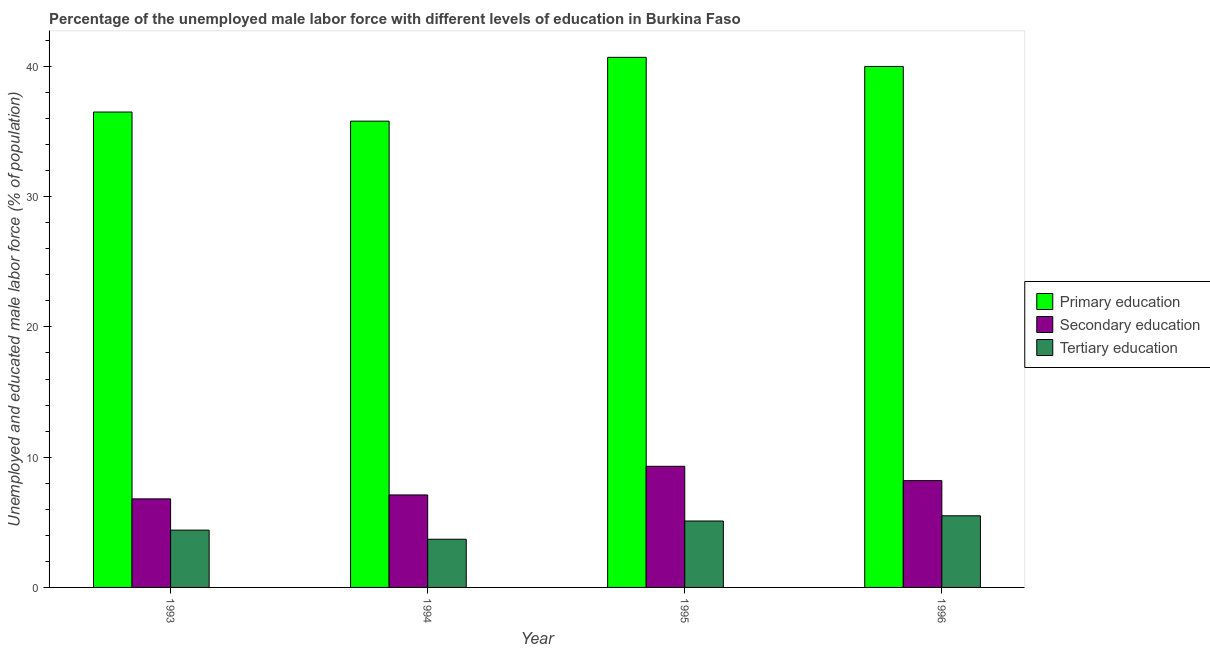How many bars are there on the 3rd tick from the right?
Your answer should be very brief. 3. What is the percentage of male labor force who received tertiary education in 1995?
Your response must be concise. 5.1. Across all years, what is the maximum percentage of male labor force who received secondary education?
Give a very brief answer. 9.3. Across all years, what is the minimum percentage of male labor force who received tertiary education?
Keep it short and to the point. 3.7. In which year was the percentage of male labor force who received secondary education maximum?
Keep it short and to the point. 1995. In which year was the percentage of male labor force who received primary education minimum?
Give a very brief answer. 1994. What is the total percentage of male labor force who received tertiary education in the graph?
Offer a terse response. 18.7. What is the difference between the percentage of male labor force who received secondary education in 1993 and that in 1996?
Ensure brevity in your answer.  -1.4. What is the difference between the percentage of male labor force who received tertiary education in 1993 and the percentage of male labor force who received secondary education in 1994?
Offer a terse response. 0.7. What is the average percentage of male labor force who received tertiary education per year?
Your answer should be very brief. 4.68. In how many years, is the percentage of male labor force who received primary education greater than 4 %?
Offer a very short reply. 4. What is the ratio of the percentage of male labor force who received primary education in 1994 to that in 1996?
Your answer should be very brief. 0.89. Is the percentage of male labor force who received tertiary education in 1993 less than that in 1995?
Give a very brief answer. Yes. Is the difference between the percentage of male labor force who received primary education in 1995 and 1996 greater than the difference between the percentage of male labor force who received secondary education in 1995 and 1996?
Provide a succinct answer. No. What is the difference between the highest and the second highest percentage of male labor force who received tertiary education?
Ensure brevity in your answer.  0.4. What is the difference between the highest and the lowest percentage of male labor force who received primary education?
Your answer should be compact. 4.9. Is the sum of the percentage of male labor force who received secondary education in 1994 and 1996 greater than the maximum percentage of male labor force who received primary education across all years?
Keep it short and to the point. Yes. What does the 3rd bar from the left in 1994 represents?
Your answer should be very brief. Tertiary education. What does the 2nd bar from the right in 1993 represents?
Your answer should be very brief. Secondary education. How many bars are there?
Your response must be concise. 12. Are all the bars in the graph horizontal?
Make the answer very short. No. How many years are there in the graph?
Make the answer very short. 4. Where does the legend appear in the graph?
Offer a very short reply. Center right. How many legend labels are there?
Offer a very short reply. 3. How are the legend labels stacked?
Ensure brevity in your answer.  Vertical. What is the title of the graph?
Ensure brevity in your answer.  Percentage of the unemployed male labor force with different levels of education in Burkina Faso. What is the label or title of the Y-axis?
Provide a short and direct response. Unemployed and educated male labor force (% of population). What is the Unemployed and educated male labor force (% of population) in Primary education in 1993?
Offer a terse response. 36.5. What is the Unemployed and educated male labor force (% of population) in Secondary education in 1993?
Make the answer very short. 6.8. What is the Unemployed and educated male labor force (% of population) of Tertiary education in 1993?
Your answer should be compact. 4.4. What is the Unemployed and educated male labor force (% of population) of Primary education in 1994?
Provide a short and direct response. 35.8. What is the Unemployed and educated male labor force (% of population) in Secondary education in 1994?
Give a very brief answer. 7.1. What is the Unemployed and educated male labor force (% of population) in Tertiary education in 1994?
Your response must be concise. 3.7. What is the Unemployed and educated male labor force (% of population) of Primary education in 1995?
Ensure brevity in your answer.  40.7. What is the Unemployed and educated male labor force (% of population) in Secondary education in 1995?
Keep it short and to the point. 9.3. What is the Unemployed and educated male labor force (% of population) of Tertiary education in 1995?
Offer a terse response. 5.1. What is the Unemployed and educated male labor force (% of population) of Secondary education in 1996?
Provide a succinct answer. 8.2. Across all years, what is the maximum Unemployed and educated male labor force (% of population) of Primary education?
Keep it short and to the point. 40.7. Across all years, what is the maximum Unemployed and educated male labor force (% of population) in Secondary education?
Offer a terse response. 9.3. Across all years, what is the maximum Unemployed and educated male labor force (% of population) in Tertiary education?
Give a very brief answer. 5.5. Across all years, what is the minimum Unemployed and educated male labor force (% of population) of Primary education?
Your response must be concise. 35.8. Across all years, what is the minimum Unemployed and educated male labor force (% of population) of Secondary education?
Give a very brief answer. 6.8. Across all years, what is the minimum Unemployed and educated male labor force (% of population) in Tertiary education?
Your answer should be very brief. 3.7. What is the total Unemployed and educated male labor force (% of population) in Primary education in the graph?
Keep it short and to the point. 153. What is the total Unemployed and educated male labor force (% of population) in Secondary education in the graph?
Give a very brief answer. 31.4. What is the total Unemployed and educated male labor force (% of population) in Tertiary education in the graph?
Your response must be concise. 18.7. What is the difference between the Unemployed and educated male labor force (% of population) in Secondary education in 1993 and that in 1994?
Offer a very short reply. -0.3. What is the difference between the Unemployed and educated male labor force (% of population) of Tertiary education in 1993 and that in 1994?
Offer a very short reply. 0.7. What is the difference between the Unemployed and educated male labor force (% of population) of Secondary education in 1993 and that in 1995?
Your response must be concise. -2.5. What is the difference between the Unemployed and educated male labor force (% of population) in Tertiary education in 1993 and that in 1995?
Ensure brevity in your answer.  -0.7. What is the difference between the Unemployed and educated male labor force (% of population) in Secondary education in 1993 and that in 1996?
Keep it short and to the point. -1.4. What is the difference between the Unemployed and educated male labor force (% of population) in Tertiary education in 1993 and that in 1996?
Your response must be concise. -1.1. What is the difference between the Unemployed and educated male labor force (% of population) of Tertiary education in 1994 and that in 1995?
Provide a short and direct response. -1.4. What is the difference between the Unemployed and educated male labor force (% of population) of Primary education in 1994 and that in 1996?
Provide a succinct answer. -4.2. What is the difference between the Unemployed and educated male labor force (% of population) of Primary education in 1995 and that in 1996?
Keep it short and to the point. 0.7. What is the difference between the Unemployed and educated male labor force (% of population) in Primary education in 1993 and the Unemployed and educated male labor force (% of population) in Secondary education in 1994?
Provide a short and direct response. 29.4. What is the difference between the Unemployed and educated male labor force (% of population) of Primary education in 1993 and the Unemployed and educated male labor force (% of population) of Tertiary education in 1994?
Your answer should be very brief. 32.8. What is the difference between the Unemployed and educated male labor force (% of population) of Secondary education in 1993 and the Unemployed and educated male labor force (% of population) of Tertiary education in 1994?
Your answer should be very brief. 3.1. What is the difference between the Unemployed and educated male labor force (% of population) of Primary education in 1993 and the Unemployed and educated male labor force (% of population) of Secondary education in 1995?
Offer a very short reply. 27.2. What is the difference between the Unemployed and educated male labor force (% of population) of Primary education in 1993 and the Unemployed and educated male labor force (% of population) of Tertiary education in 1995?
Provide a succinct answer. 31.4. What is the difference between the Unemployed and educated male labor force (% of population) of Secondary education in 1993 and the Unemployed and educated male labor force (% of population) of Tertiary education in 1995?
Offer a terse response. 1.7. What is the difference between the Unemployed and educated male labor force (% of population) in Primary education in 1993 and the Unemployed and educated male labor force (% of population) in Secondary education in 1996?
Make the answer very short. 28.3. What is the difference between the Unemployed and educated male labor force (% of population) of Secondary education in 1993 and the Unemployed and educated male labor force (% of population) of Tertiary education in 1996?
Provide a short and direct response. 1.3. What is the difference between the Unemployed and educated male labor force (% of population) in Primary education in 1994 and the Unemployed and educated male labor force (% of population) in Secondary education in 1995?
Make the answer very short. 26.5. What is the difference between the Unemployed and educated male labor force (% of population) in Primary education in 1994 and the Unemployed and educated male labor force (% of population) in Tertiary education in 1995?
Provide a short and direct response. 30.7. What is the difference between the Unemployed and educated male labor force (% of population) in Primary education in 1994 and the Unemployed and educated male labor force (% of population) in Secondary education in 1996?
Your response must be concise. 27.6. What is the difference between the Unemployed and educated male labor force (% of population) in Primary education in 1994 and the Unemployed and educated male labor force (% of population) in Tertiary education in 1996?
Your response must be concise. 30.3. What is the difference between the Unemployed and educated male labor force (% of population) of Secondary education in 1994 and the Unemployed and educated male labor force (% of population) of Tertiary education in 1996?
Your answer should be compact. 1.6. What is the difference between the Unemployed and educated male labor force (% of population) of Primary education in 1995 and the Unemployed and educated male labor force (% of population) of Secondary education in 1996?
Provide a succinct answer. 32.5. What is the difference between the Unemployed and educated male labor force (% of population) in Primary education in 1995 and the Unemployed and educated male labor force (% of population) in Tertiary education in 1996?
Ensure brevity in your answer.  35.2. What is the difference between the Unemployed and educated male labor force (% of population) in Secondary education in 1995 and the Unemployed and educated male labor force (% of population) in Tertiary education in 1996?
Provide a short and direct response. 3.8. What is the average Unemployed and educated male labor force (% of population) in Primary education per year?
Your answer should be compact. 38.25. What is the average Unemployed and educated male labor force (% of population) of Secondary education per year?
Your answer should be very brief. 7.85. What is the average Unemployed and educated male labor force (% of population) in Tertiary education per year?
Make the answer very short. 4.67. In the year 1993, what is the difference between the Unemployed and educated male labor force (% of population) in Primary education and Unemployed and educated male labor force (% of population) in Secondary education?
Your response must be concise. 29.7. In the year 1993, what is the difference between the Unemployed and educated male labor force (% of population) of Primary education and Unemployed and educated male labor force (% of population) of Tertiary education?
Your answer should be compact. 32.1. In the year 1994, what is the difference between the Unemployed and educated male labor force (% of population) in Primary education and Unemployed and educated male labor force (% of population) in Secondary education?
Make the answer very short. 28.7. In the year 1994, what is the difference between the Unemployed and educated male labor force (% of population) in Primary education and Unemployed and educated male labor force (% of population) in Tertiary education?
Your answer should be very brief. 32.1. In the year 1995, what is the difference between the Unemployed and educated male labor force (% of population) in Primary education and Unemployed and educated male labor force (% of population) in Secondary education?
Your answer should be compact. 31.4. In the year 1995, what is the difference between the Unemployed and educated male labor force (% of population) in Primary education and Unemployed and educated male labor force (% of population) in Tertiary education?
Provide a succinct answer. 35.6. In the year 1995, what is the difference between the Unemployed and educated male labor force (% of population) of Secondary education and Unemployed and educated male labor force (% of population) of Tertiary education?
Provide a succinct answer. 4.2. In the year 1996, what is the difference between the Unemployed and educated male labor force (% of population) in Primary education and Unemployed and educated male labor force (% of population) in Secondary education?
Your answer should be very brief. 31.8. In the year 1996, what is the difference between the Unemployed and educated male labor force (% of population) of Primary education and Unemployed and educated male labor force (% of population) of Tertiary education?
Keep it short and to the point. 34.5. In the year 1996, what is the difference between the Unemployed and educated male labor force (% of population) in Secondary education and Unemployed and educated male labor force (% of population) in Tertiary education?
Give a very brief answer. 2.7. What is the ratio of the Unemployed and educated male labor force (% of population) of Primary education in 1993 to that in 1994?
Your answer should be very brief. 1.02. What is the ratio of the Unemployed and educated male labor force (% of population) in Secondary education in 1993 to that in 1994?
Your answer should be compact. 0.96. What is the ratio of the Unemployed and educated male labor force (% of population) in Tertiary education in 1993 to that in 1994?
Your answer should be compact. 1.19. What is the ratio of the Unemployed and educated male labor force (% of population) of Primary education in 1993 to that in 1995?
Ensure brevity in your answer.  0.9. What is the ratio of the Unemployed and educated male labor force (% of population) of Secondary education in 1993 to that in 1995?
Your answer should be compact. 0.73. What is the ratio of the Unemployed and educated male labor force (% of population) in Tertiary education in 1993 to that in 1995?
Give a very brief answer. 0.86. What is the ratio of the Unemployed and educated male labor force (% of population) of Primary education in 1993 to that in 1996?
Make the answer very short. 0.91. What is the ratio of the Unemployed and educated male labor force (% of population) in Secondary education in 1993 to that in 1996?
Make the answer very short. 0.83. What is the ratio of the Unemployed and educated male labor force (% of population) in Primary education in 1994 to that in 1995?
Your answer should be compact. 0.88. What is the ratio of the Unemployed and educated male labor force (% of population) of Secondary education in 1994 to that in 1995?
Give a very brief answer. 0.76. What is the ratio of the Unemployed and educated male labor force (% of population) of Tertiary education in 1994 to that in 1995?
Your response must be concise. 0.73. What is the ratio of the Unemployed and educated male labor force (% of population) of Primary education in 1994 to that in 1996?
Your answer should be very brief. 0.9. What is the ratio of the Unemployed and educated male labor force (% of population) in Secondary education in 1994 to that in 1996?
Provide a succinct answer. 0.87. What is the ratio of the Unemployed and educated male labor force (% of population) of Tertiary education in 1994 to that in 1996?
Keep it short and to the point. 0.67. What is the ratio of the Unemployed and educated male labor force (% of population) in Primary education in 1995 to that in 1996?
Keep it short and to the point. 1.02. What is the ratio of the Unemployed and educated male labor force (% of population) of Secondary education in 1995 to that in 1996?
Give a very brief answer. 1.13. What is the ratio of the Unemployed and educated male labor force (% of population) in Tertiary education in 1995 to that in 1996?
Your response must be concise. 0.93. What is the difference between the highest and the second highest Unemployed and educated male labor force (% of population) in Primary education?
Your response must be concise. 0.7. What is the difference between the highest and the lowest Unemployed and educated male labor force (% of population) in Primary education?
Ensure brevity in your answer.  4.9. 